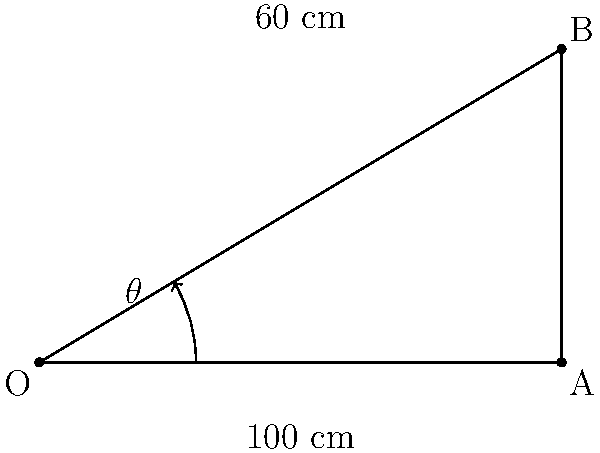In a tennis serve, the ball follows a trajectory as shown in the diagram. If the ball travels 100 cm horizontally and reaches a maximum height of 60 cm, what is the angle $\theta$ of the serve (in degrees) relative to the horizontal? To solve this problem, we can use trigonometry. Let's follow these steps:

1) The trajectory forms a right-angled triangle with the following measurements:
   - Base (horizontal distance) = 100 cm
   - Height (vertical distance) = 60 cm
   - Hypotenuse (trajectory of the ball)

2) We need to find the angle $\theta$ between the hypotenuse and the base.

3) In a right-angled triangle, the tangent of an angle is the ratio of the opposite side to the adjacent side.

4) In this case:
   $\tan(\theta) = \frac{\text{opposite}}{\text{adjacent}} = \frac{60}{100} = 0.6$

5) To find $\theta$, we need to take the inverse tangent (arctan or $\tan^{-1}$) of this ratio:
   $\theta = \tan^{-1}(0.6)$

6) Using a calculator or trigonometric tables:
   $\theta \approx 30.96^\circ$

7) Rounding to the nearest degree:
   $\theta \approx 31^\circ$
Answer: $31^\circ$ 